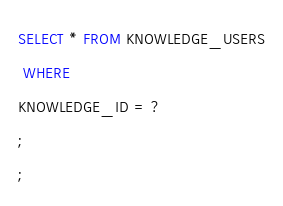<code> <loc_0><loc_0><loc_500><loc_500><_SQL_>SELECT * FROM KNOWLEDGE_USERS
 WHERE 
KNOWLEDGE_ID = ?
;
;
</code> 